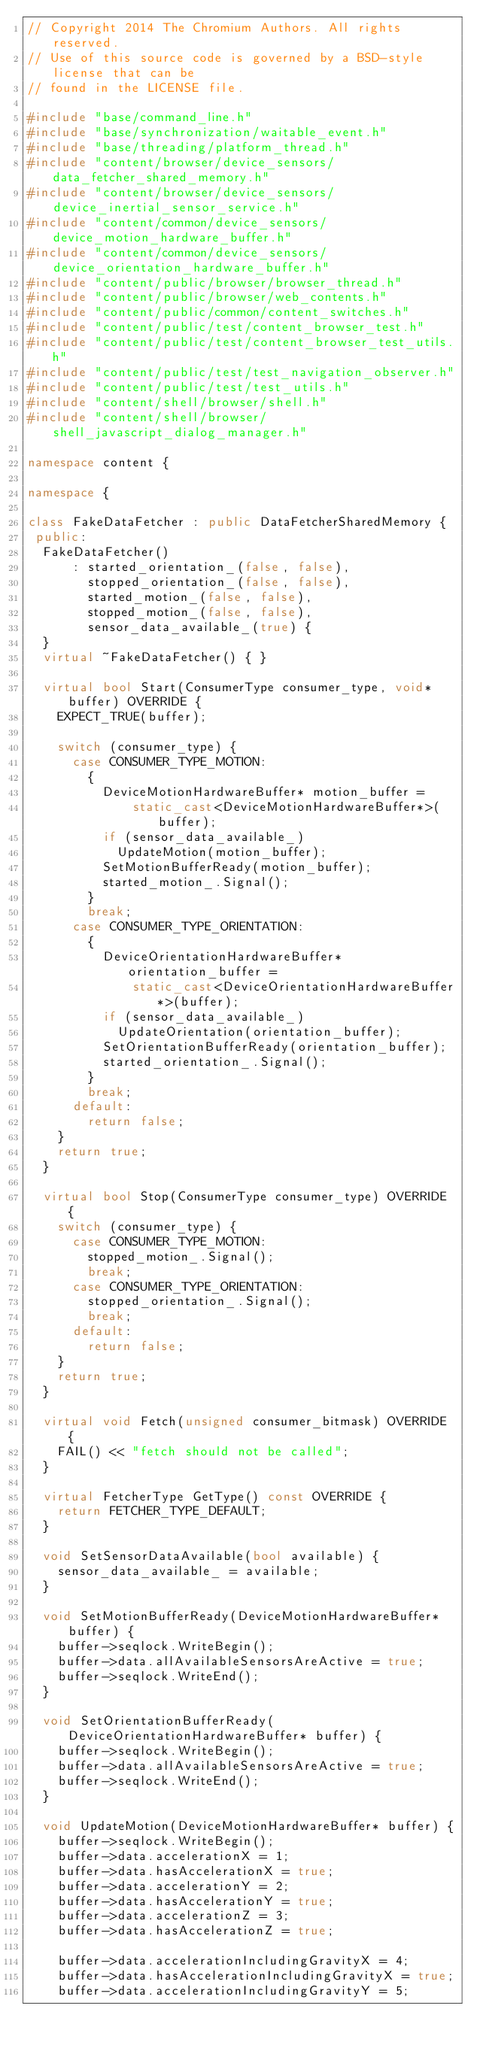Convert code to text. <code><loc_0><loc_0><loc_500><loc_500><_C++_>// Copyright 2014 The Chromium Authors. All rights reserved.
// Use of this source code is governed by a BSD-style license that can be
// found in the LICENSE file.

#include "base/command_line.h"
#include "base/synchronization/waitable_event.h"
#include "base/threading/platform_thread.h"
#include "content/browser/device_sensors/data_fetcher_shared_memory.h"
#include "content/browser/device_sensors/device_inertial_sensor_service.h"
#include "content/common/device_sensors/device_motion_hardware_buffer.h"
#include "content/common/device_sensors/device_orientation_hardware_buffer.h"
#include "content/public/browser/browser_thread.h"
#include "content/public/browser/web_contents.h"
#include "content/public/common/content_switches.h"
#include "content/public/test/content_browser_test.h"
#include "content/public/test/content_browser_test_utils.h"
#include "content/public/test/test_navigation_observer.h"
#include "content/public/test/test_utils.h"
#include "content/shell/browser/shell.h"
#include "content/shell/browser/shell_javascript_dialog_manager.h"

namespace content {

namespace {

class FakeDataFetcher : public DataFetcherSharedMemory {
 public:
  FakeDataFetcher()
      : started_orientation_(false, false),
        stopped_orientation_(false, false),
        started_motion_(false, false),
        stopped_motion_(false, false),
        sensor_data_available_(true) {
  }
  virtual ~FakeDataFetcher() { }

  virtual bool Start(ConsumerType consumer_type, void* buffer) OVERRIDE {
    EXPECT_TRUE(buffer);

    switch (consumer_type) {
      case CONSUMER_TYPE_MOTION:
        {
          DeviceMotionHardwareBuffer* motion_buffer =
              static_cast<DeviceMotionHardwareBuffer*>(buffer);
          if (sensor_data_available_)
            UpdateMotion(motion_buffer);
          SetMotionBufferReady(motion_buffer);
          started_motion_.Signal();
        }
        break;
      case CONSUMER_TYPE_ORIENTATION:
        {
          DeviceOrientationHardwareBuffer* orientation_buffer =
              static_cast<DeviceOrientationHardwareBuffer*>(buffer);
          if (sensor_data_available_)
            UpdateOrientation(orientation_buffer);
          SetOrientationBufferReady(orientation_buffer);
          started_orientation_.Signal();
        }
        break;
      default:
        return false;
    }
    return true;
  }

  virtual bool Stop(ConsumerType consumer_type) OVERRIDE {
    switch (consumer_type) {
      case CONSUMER_TYPE_MOTION:
        stopped_motion_.Signal();
        break;
      case CONSUMER_TYPE_ORIENTATION:
        stopped_orientation_.Signal();
        break;
      default:
        return false;
    }
    return true;
  }

  virtual void Fetch(unsigned consumer_bitmask) OVERRIDE {
    FAIL() << "fetch should not be called";
  }

  virtual FetcherType GetType() const OVERRIDE {
    return FETCHER_TYPE_DEFAULT;
  }

  void SetSensorDataAvailable(bool available) {
    sensor_data_available_ = available;
  }

  void SetMotionBufferReady(DeviceMotionHardwareBuffer* buffer) {
    buffer->seqlock.WriteBegin();
    buffer->data.allAvailableSensorsAreActive = true;
    buffer->seqlock.WriteEnd();
  }

  void SetOrientationBufferReady(DeviceOrientationHardwareBuffer* buffer) {
    buffer->seqlock.WriteBegin();
    buffer->data.allAvailableSensorsAreActive = true;
    buffer->seqlock.WriteEnd();
  }

  void UpdateMotion(DeviceMotionHardwareBuffer* buffer) {
    buffer->seqlock.WriteBegin();
    buffer->data.accelerationX = 1;
    buffer->data.hasAccelerationX = true;
    buffer->data.accelerationY = 2;
    buffer->data.hasAccelerationY = true;
    buffer->data.accelerationZ = 3;
    buffer->data.hasAccelerationZ = true;

    buffer->data.accelerationIncludingGravityX = 4;
    buffer->data.hasAccelerationIncludingGravityX = true;
    buffer->data.accelerationIncludingGravityY = 5;</code> 